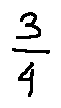Convert formula to latex. <formula><loc_0><loc_0><loc_500><loc_500>\frac { 3 } { 4 }</formula> 